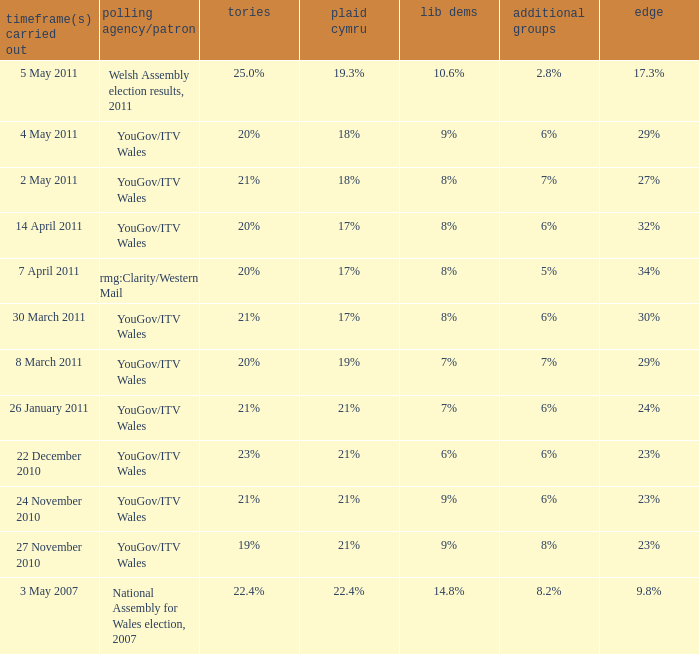What is the cons for lib dem of 8% and a lead of 27% 21%. 